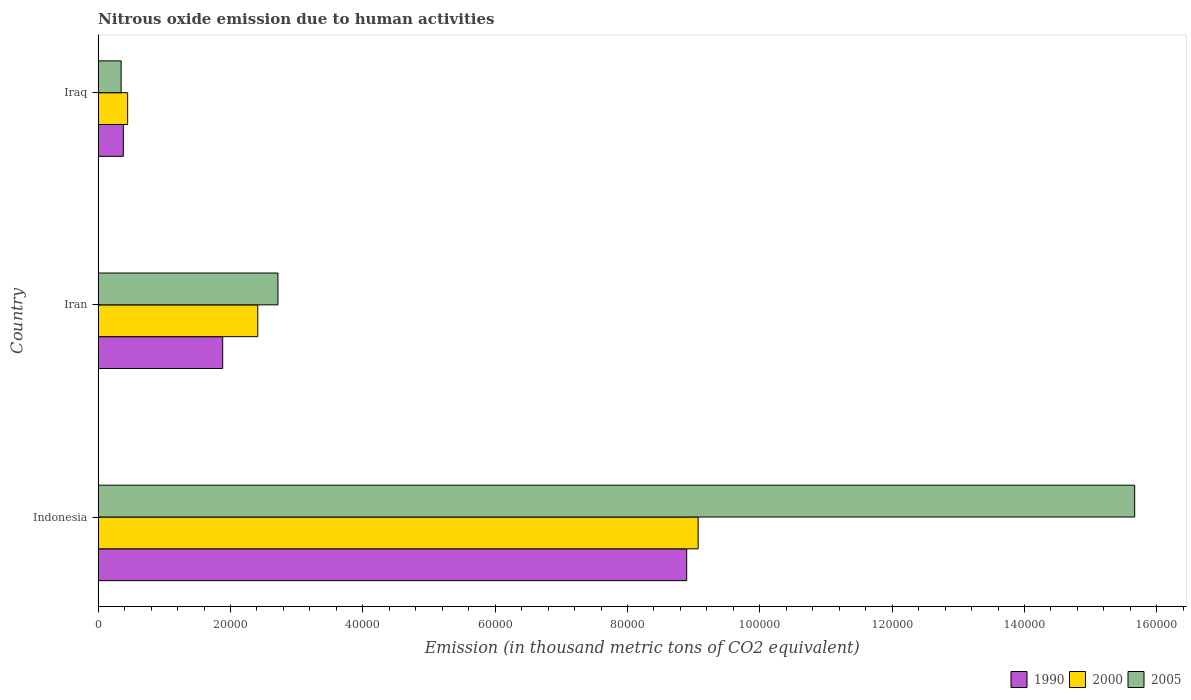Are the number of bars on each tick of the Y-axis equal?
Ensure brevity in your answer.  Yes. What is the label of the 1st group of bars from the top?
Keep it short and to the point. Iraq. In how many cases, is the number of bars for a given country not equal to the number of legend labels?
Your answer should be compact. 0. What is the amount of nitrous oxide emitted in 2000 in Iraq?
Provide a short and direct response. 4462.3. Across all countries, what is the maximum amount of nitrous oxide emitted in 2000?
Provide a short and direct response. 9.07e+04. Across all countries, what is the minimum amount of nitrous oxide emitted in 2000?
Offer a terse response. 4462.3. In which country was the amount of nitrous oxide emitted in 2005 maximum?
Provide a short and direct response. Indonesia. In which country was the amount of nitrous oxide emitted in 2005 minimum?
Make the answer very short. Iraq. What is the total amount of nitrous oxide emitted in 1990 in the graph?
Give a very brief answer. 1.12e+05. What is the difference between the amount of nitrous oxide emitted in 2000 in Indonesia and that in Iran?
Offer a terse response. 6.65e+04. What is the difference between the amount of nitrous oxide emitted in 2005 in Iraq and the amount of nitrous oxide emitted in 1990 in Indonesia?
Offer a very short reply. -8.55e+04. What is the average amount of nitrous oxide emitted in 2000 per country?
Your response must be concise. 3.98e+04. What is the difference between the amount of nitrous oxide emitted in 1990 and amount of nitrous oxide emitted in 2005 in Indonesia?
Your answer should be very brief. -6.77e+04. In how many countries, is the amount of nitrous oxide emitted in 2000 greater than 152000 thousand metric tons?
Provide a short and direct response. 0. What is the ratio of the amount of nitrous oxide emitted in 2005 in Indonesia to that in Iraq?
Ensure brevity in your answer.  45.04. Is the amount of nitrous oxide emitted in 1990 in Iran less than that in Iraq?
Provide a succinct answer. No. Is the difference between the amount of nitrous oxide emitted in 1990 in Iran and Iraq greater than the difference between the amount of nitrous oxide emitted in 2005 in Iran and Iraq?
Offer a terse response. No. What is the difference between the highest and the second highest amount of nitrous oxide emitted in 2005?
Offer a terse response. 1.29e+05. What is the difference between the highest and the lowest amount of nitrous oxide emitted in 1990?
Provide a short and direct response. 8.51e+04. In how many countries, is the amount of nitrous oxide emitted in 1990 greater than the average amount of nitrous oxide emitted in 1990 taken over all countries?
Your answer should be compact. 1. Is the sum of the amount of nitrous oxide emitted in 1990 in Indonesia and Iraq greater than the maximum amount of nitrous oxide emitted in 2000 across all countries?
Provide a succinct answer. Yes. What does the 3rd bar from the top in Iraq represents?
Give a very brief answer. 1990. What does the 3rd bar from the bottom in Iran represents?
Provide a succinct answer. 2005. How many bars are there?
Offer a very short reply. 9. What is the difference between two consecutive major ticks on the X-axis?
Your response must be concise. 2.00e+04. Are the values on the major ticks of X-axis written in scientific E-notation?
Provide a short and direct response. No. Where does the legend appear in the graph?
Your answer should be very brief. Bottom right. How are the legend labels stacked?
Offer a terse response. Horizontal. What is the title of the graph?
Your response must be concise. Nitrous oxide emission due to human activities. What is the label or title of the X-axis?
Make the answer very short. Emission (in thousand metric tons of CO2 equivalent). What is the label or title of the Y-axis?
Provide a short and direct response. Country. What is the Emission (in thousand metric tons of CO2 equivalent) of 1990 in Indonesia?
Make the answer very short. 8.89e+04. What is the Emission (in thousand metric tons of CO2 equivalent) of 2000 in Indonesia?
Your answer should be compact. 9.07e+04. What is the Emission (in thousand metric tons of CO2 equivalent) in 2005 in Indonesia?
Make the answer very short. 1.57e+05. What is the Emission (in thousand metric tons of CO2 equivalent) of 1990 in Iran?
Offer a terse response. 1.88e+04. What is the Emission (in thousand metric tons of CO2 equivalent) in 2000 in Iran?
Offer a very short reply. 2.41e+04. What is the Emission (in thousand metric tons of CO2 equivalent) of 2005 in Iran?
Ensure brevity in your answer.  2.72e+04. What is the Emission (in thousand metric tons of CO2 equivalent) in 1990 in Iraq?
Offer a terse response. 3808.9. What is the Emission (in thousand metric tons of CO2 equivalent) of 2000 in Iraq?
Offer a very short reply. 4462.3. What is the Emission (in thousand metric tons of CO2 equivalent) in 2005 in Iraq?
Provide a succinct answer. 3478.3. Across all countries, what is the maximum Emission (in thousand metric tons of CO2 equivalent) of 1990?
Offer a terse response. 8.89e+04. Across all countries, what is the maximum Emission (in thousand metric tons of CO2 equivalent) in 2000?
Keep it short and to the point. 9.07e+04. Across all countries, what is the maximum Emission (in thousand metric tons of CO2 equivalent) of 2005?
Make the answer very short. 1.57e+05. Across all countries, what is the minimum Emission (in thousand metric tons of CO2 equivalent) in 1990?
Provide a succinct answer. 3808.9. Across all countries, what is the minimum Emission (in thousand metric tons of CO2 equivalent) of 2000?
Provide a succinct answer. 4462.3. Across all countries, what is the minimum Emission (in thousand metric tons of CO2 equivalent) in 2005?
Offer a very short reply. 3478.3. What is the total Emission (in thousand metric tons of CO2 equivalent) of 1990 in the graph?
Give a very brief answer. 1.12e+05. What is the total Emission (in thousand metric tons of CO2 equivalent) in 2000 in the graph?
Offer a very short reply. 1.19e+05. What is the total Emission (in thousand metric tons of CO2 equivalent) of 2005 in the graph?
Keep it short and to the point. 1.87e+05. What is the difference between the Emission (in thousand metric tons of CO2 equivalent) of 1990 in Indonesia and that in Iran?
Ensure brevity in your answer.  7.01e+04. What is the difference between the Emission (in thousand metric tons of CO2 equivalent) of 2000 in Indonesia and that in Iran?
Offer a very short reply. 6.65e+04. What is the difference between the Emission (in thousand metric tons of CO2 equivalent) of 2005 in Indonesia and that in Iran?
Make the answer very short. 1.29e+05. What is the difference between the Emission (in thousand metric tons of CO2 equivalent) of 1990 in Indonesia and that in Iraq?
Your response must be concise. 8.51e+04. What is the difference between the Emission (in thousand metric tons of CO2 equivalent) in 2000 in Indonesia and that in Iraq?
Offer a very short reply. 8.62e+04. What is the difference between the Emission (in thousand metric tons of CO2 equivalent) in 2005 in Indonesia and that in Iraq?
Your response must be concise. 1.53e+05. What is the difference between the Emission (in thousand metric tons of CO2 equivalent) of 1990 in Iran and that in Iraq?
Make the answer very short. 1.50e+04. What is the difference between the Emission (in thousand metric tons of CO2 equivalent) in 2000 in Iran and that in Iraq?
Offer a very short reply. 1.97e+04. What is the difference between the Emission (in thousand metric tons of CO2 equivalent) of 2005 in Iran and that in Iraq?
Offer a very short reply. 2.37e+04. What is the difference between the Emission (in thousand metric tons of CO2 equivalent) of 1990 in Indonesia and the Emission (in thousand metric tons of CO2 equivalent) of 2000 in Iran?
Make the answer very short. 6.48e+04. What is the difference between the Emission (in thousand metric tons of CO2 equivalent) of 1990 in Indonesia and the Emission (in thousand metric tons of CO2 equivalent) of 2005 in Iran?
Give a very brief answer. 6.18e+04. What is the difference between the Emission (in thousand metric tons of CO2 equivalent) of 2000 in Indonesia and the Emission (in thousand metric tons of CO2 equivalent) of 2005 in Iran?
Provide a succinct answer. 6.35e+04. What is the difference between the Emission (in thousand metric tons of CO2 equivalent) of 1990 in Indonesia and the Emission (in thousand metric tons of CO2 equivalent) of 2000 in Iraq?
Your answer should be compact. 8.45e+04. What is the difference between the Emission (in thousand metric tons of CO2 equivalent) of 1990 in Indonesia and the Emission (in thousand metric tons of CO2 equivalent) of 2005 in Iraq?
Your answer should be compact. 8.55e+04. What is the difference between the Emission (in thousand metric tons of CO2 equivalent) in 2000 in Indonesia and the Emission (in thousand metric tons of CO2 equivalent) in 2005 in Iraq?
Your answer should be compact. 8.72e+04. What is the difference between the Emission (in thousand metric tons of CO2 equivalent) of 1990 in Iran and the Emission (in thousand metric tons of CO2 equivalent) of 2000 in Iraq?
Keep it short and to the point. 1.44e+04. What is the difference between the Emission (in thousand metric tons of CO2 equivalent) in 1990 in Iran and the Emission (in thousand metric tons of CO2 equivalent) in 2005 in Iraq?
Your answer should be compact. 1.53e+04. What is the difference between the Emission (in thousand metric tons of CO2 equivalent) of 2000 in Iran and the Emission (in thousand metric tons of CO2 equivalent) of 2005 in Iraq?
Provide a short and direct response. 2.06e+04. What is the average Emission (in thousand metric tons of CO2 equivalent) in 1990 per country?
Ensure brevity in your answer.  3.72e+04. What is the average Emission (in thousand metric tons of CO2 equivalent) in 2000 per country?
Ensure brevity in your answer.  3.98e+04. What is the average Emission (in thousand metric tons of CO2 equivalent) of 2005 per country?
Your answer should be compact. 6.24e+04. What is the difference between the Emission (in thousand metric tons of CO2 equivalent) of 1990 and Emission (in thousand metric tons of CO2 equivalent) of 2000 in Indonesia?
Keep it short and to the point. -1727.1. What is the difference between the Emission (in thousand metric tons of CO2 equivalent) in 1990 and Emission (in thousand metric tons of CO2 equivalent) in 2005 in Indonesia?
Your response must be concise. -6.77e+04. What is the difference between the Emission (in thousand metric tons of CO2 equivalent) in 2000 and Emission (in thousand metric tons of CO2 equivalent) in 2005 in Indonesia?
Your response must be concise. -6.60e+04. What is the difference between the Emission (in thousand metric tons of CO2 equivalent) in 1990 and Emission (in thousand metric tons of CO2 equivalent) in 2000 in Iran?
Give a very brief answer. -5303. What is the difference between the Emission (in thousand metric tons of CO2 equivalent) of 1990 and Emission (in thousand metric tons of CO2 equivalent) of 2005 in Iran?
Your response must be concise. -8355.6. What is the difference between the Emission (in thousand metric tons of CO2 equivalent) of 2000 and Emission (in thousand metric tons of CO2 equivalent) of 2005 in Iran?
Your response must be concise. -3052.6. What is the difference between the Emission (in thousand metric tons of CO2 equivalent) in 1990 and Emission (in thousand metric tons of CO2 equivalent) in 2000 in Iraq?
Offer a very short reply. -653.4. What is the difference between the Emission (in thousand metric tons of CO2 equivalent) of 1990 and Emission (in thousand metric tons of CO2 equivalent) of 2005 in Iraq?
Keep it short and to the point. 330.6. What is the difference between the Emission (in thousand metric tons of CO2 equivalent) in 2000 and Emission (in thousand metric tons of CO2 equivalent) in 2005 in Iraq?
Your answer should be compact. 984. What is the ratio of the Emission (in thousand metric tons of CO2 equivalent) of 1990 in Indonesia to that in Iran?
Provide a short and direct response. 4.73. What is the ratio of the Emission (in thousand metric tons of CO2 equivalent) of 2000 in Indonesia to that in Iran?
Make the answer very short. 3.76. What is the ratio of the Emission (in thousand metric tons of CO2 equivalent) in 2005 in Indonesia to that in Iran?
Provide a short and direct response. 5.76. What is the ratio of the Emission (in thousand metric tons of CO2 equivalent) of 1990 in Indonesia to that in Iraq?
Offer a terse response. 23.35. What is the ratio of the Emission (in thousand metric tons of CO2 equivalent) of 2000 in Indonesia to that in Iraq?
Offer a very short reply. 20.32. What is the ratio of the Emission (in thousand metric tons of CO2 equivalent) in 2005 in Indonesia to that in Iraq?
Keep it short and to the point. 45.03. What is the ratio of the Emission (in thousand metric tons of CO2 equivalent) in 1990 in Iran to that in Iraq?
Make the answer very short. 4.94. What is the ratio of the Emission (in thousand metric tons of CO2 equivalent) in 2000 in Iran to that in Iraq?
Keep it short and to the point. 5.41. What is the ratio of the Emission (in thousand metric tons of CO2 equivalent) of 2005 in Iran to that in Iraq?
Give a very brief answer. 7.81. What is the difference between the highest and the second highest Emission (in thousand metric tons of CO2 equivalent) of 1990?
Your answer should be very brief. 7.01e+04. What is the difference between the highest and the second highest Emission (in thousand metric tons of CO2 equivalent) in 2000?
Ensure brevity in your answer.  6.65e+04. What is the difference between the highest and the second highest Emission (in thousand metric tons of CO2 equivalent) of 2005?
Offer a very short reply. 1.29e+05. What is the difference between the highest and the lowest Emission (in thousand metric tons of CO2 equivalent) of 1990?
Your response must be concise. 8.51e+04. What is the difference between the highest and the lowest Emission (in thousand metric tons of CO2 equivalent) in 2000?
Your answer should be compact. 8.62e+04. What is the difference between the highest and the lowest Emission (in thousand metric tons of CO2 equivalent) of 2005?
Your answer should be very brief. 1.53e+05. 